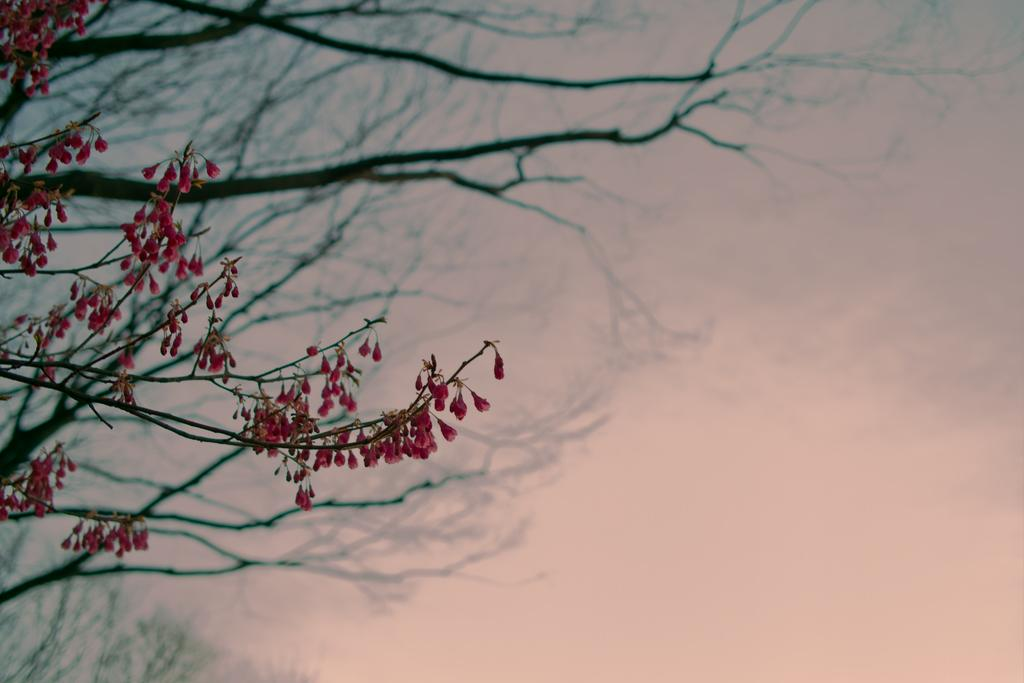What color are the flowers in the image? The flowers in the image are pink. Are the flowers part of a larger plant or structure? Yes, the flowers are associated with a tree. On which side of the image is the tree located? The tree is on the left side of the image. How far away is the toy from the flowers in the image? There is no toy present in the image, so it cannot be determined how far away it might be from the flowers. 